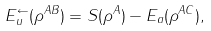Convert formula to latex. <formula><loc_0><loc_0><loc_500><loc_500>E _ { u } ^ { \leftarrow } ( \rho ^ { A B } ) = S ( \rho ^ { A } ) - E _ { a } ( \rho ^ { A C } ) ,</formula> 